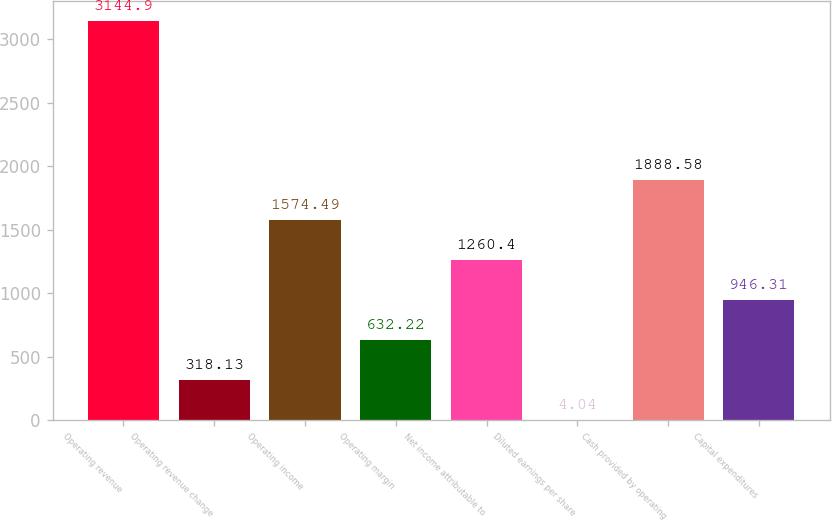Convert chart to OTSL. <chart><loc_0><loc_0><loc_500><loc_500><bar_chart><fcel>Operating revenue<fcel>Operating revenue change<fcel>Operating income<fcel>Operating margin<fcel>Net income attributable to<fcel>Diluted earnings per share<fcel>Cash provided by operating<fcel>Capital expenditures<nl><fcel>3144.9<fcel>318.13<fcel>1574.49<fcel>632.22<fcel>1260.4<fcel>4.04<fcel>1888.58<fcel>946.31<nl></chart> 